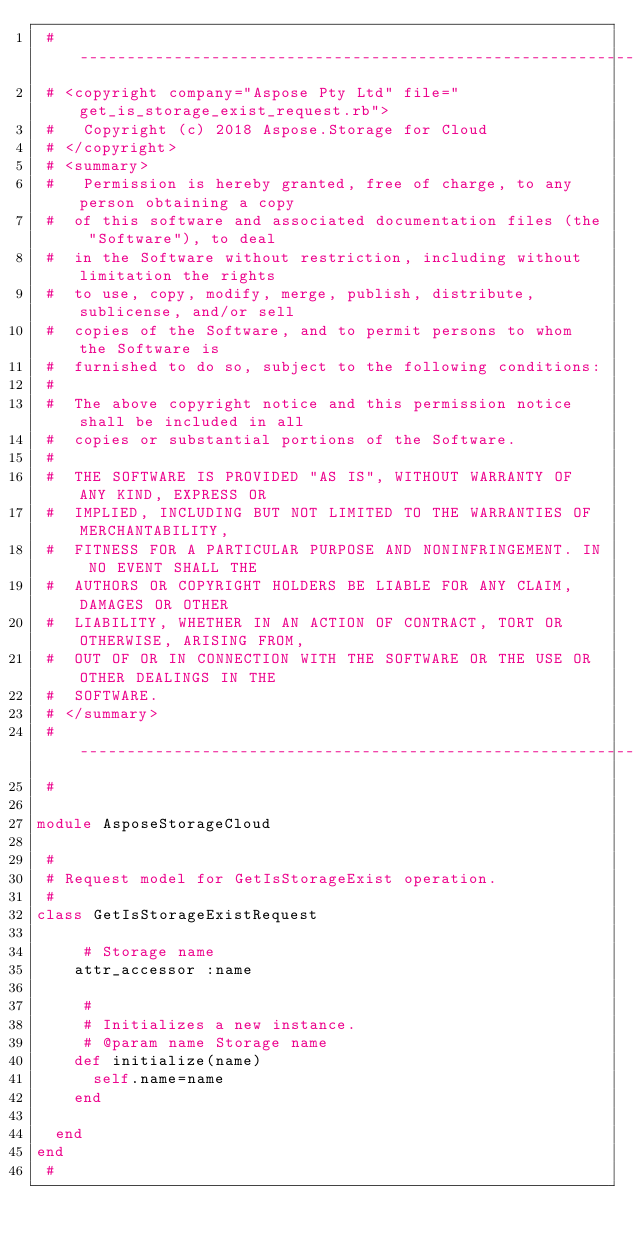Convert code to text. <code><loc_0><loc_0><loc_500><loc_500><_Ruby_> # --------------------------------------------------------------------------------------------------------------------
 # <copyright company="Aspose Pty Ltd" file="get_is_storage_exist_request.rb">
 #   Copyright (c) 2018 Aspose.Storage for Cloud
 # </copyright>
 # <summary>
 #   Permission is hereby granted, free of charge, to any person obtaining a copy
 #  of this software and associated documentation files (the "Software"), to deal
 #  in the Software without restriction, including without limitation the rights
 #  to use, copy, modify, merge, publish, distribute, sublicense, and/or sell
 #  copies of the Software, and to permit persons to whom the Software is
 #  furnished to do so, subject to the following conditions:
 # 
 #  The above copyright notice and this permission notice shall be included in all
 #  copies or substantial portions of the Software.
 # 
 #  THE SOFTWARE IS PROVIDED "AS IS", WITHOUT WARRANTY OF ANY KIND, EXPRESS OR
 #  IMPLIED, INCLUDING BUT NOT LIMITED TO THE WARRANTIES OF MERCHANTABILITY,
 #  FITNESS FOR A PARTICULAR PURPOSE AND NONINFRINGEMENT. IN NO EVENT SHALL THE
 #  AUTHORS OR COPYRIGHT HOLDERS BE LIABLE FOR ANY CLAIM, DAMAGES OR OTHER
 #  LIABILITY, WHETHER IN AN ACTION OF CONTRACT, TORT OR OTHERWISE, ARISING FROM,
 #  OUT OF OR IN CONNECTION WITH THE SOFTWARE OR THE USE OR OTHER DEALINGS IN THE
 #  SOFTWARE.
 # </summary>
 # --------------------------------------------------------------------------------------------------------------------
 #

module AsposeStorageCloud

 #
 # Request model for GetIsStorageExist operation.
 #
class GetIsStorageExistRequest

     # Storage name
		attr_accessor :name
	
     #
     # Initializes a new instance.
     # @param name Storage name
		def initialize(name)
			self.name=name
		end
	
	end
end
 #
</code> 